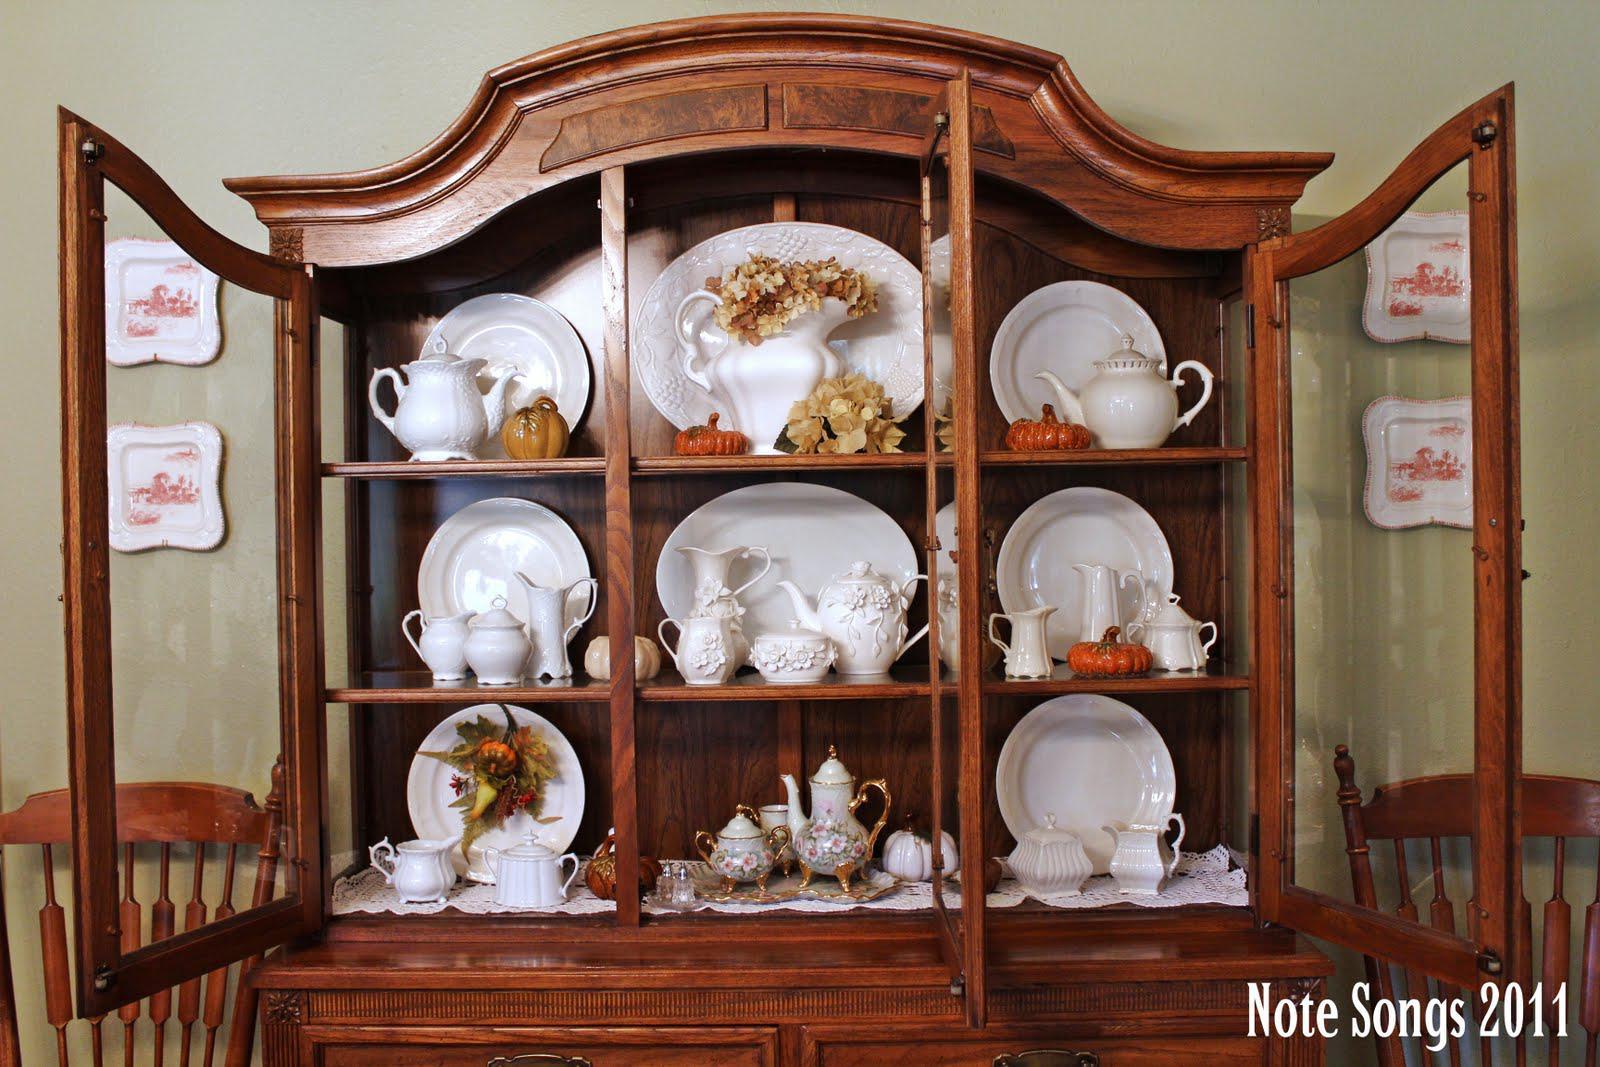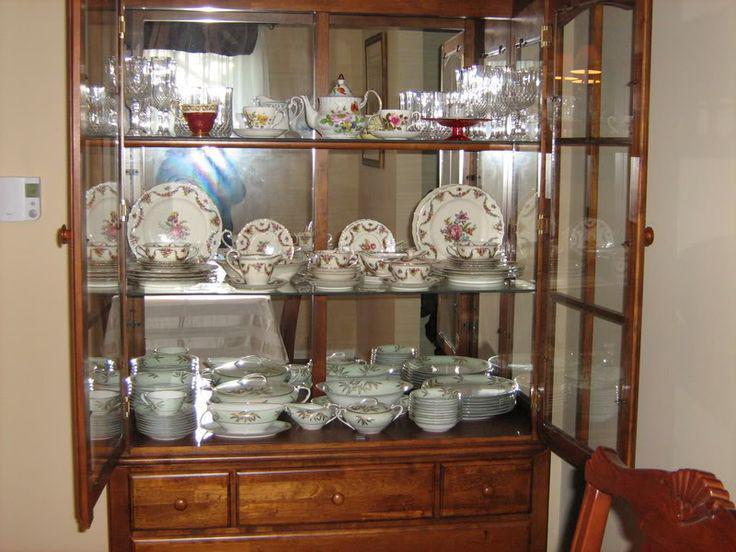The first image is the image on the left, the second image is the image on the right. For the images displayed, is the sentence "An image shows a brown cabinet with an arched top and open doors." factually correct? Answer yes or no. Yes. 